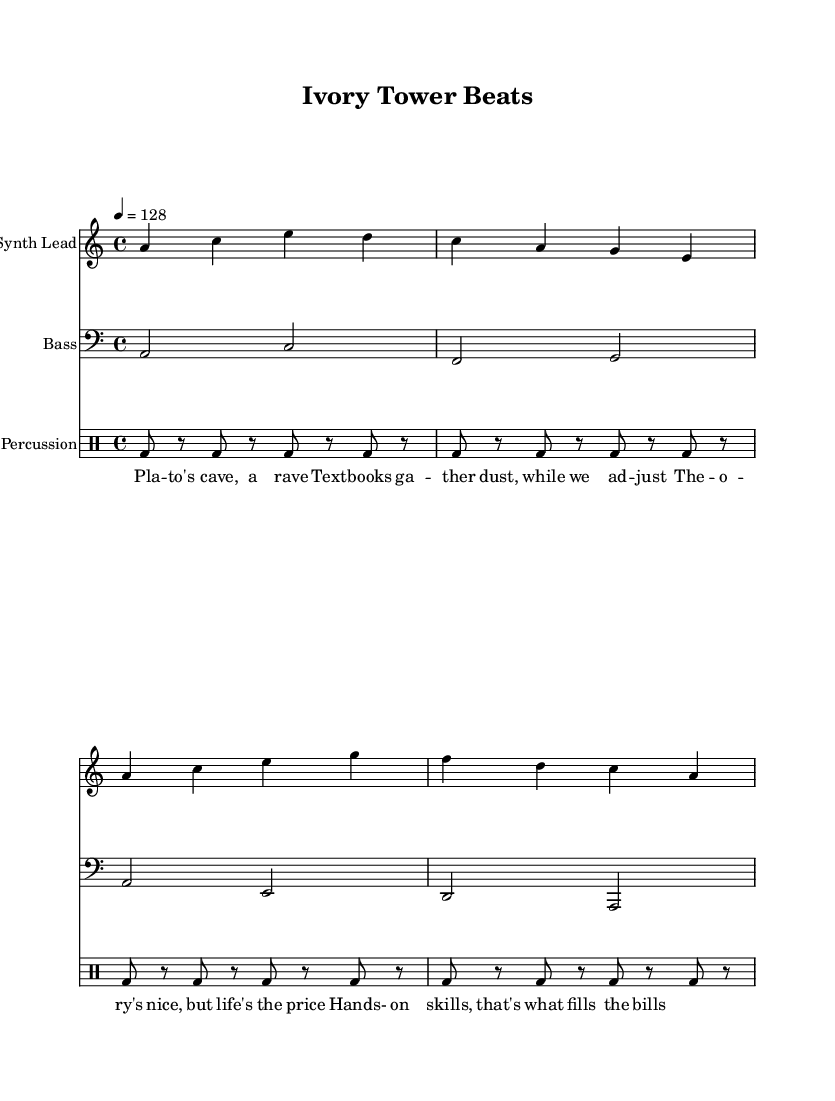What is the key signature of this music? The key signature in the piece is A minor, which is indicated by one sharp in the key signature box; A minor is the relative minor of C major.
Answer: A minor What is the time signature of this piece? The time signature, shown at the beginning of the score, is 4/4, meaning there are four beats in each measure and the quarter note gets one beat.
Answer: 4/4 What is the tempo marking for the music? The tempo marking indicates a speed of 128 beats per minute, as seen next to the tempo indication "4 = 128." This indicates the speed at which the piece should be performed.
Answer: 128 How many measures are in the synth lead part? By counting the vertical lines (bar lines) after each grouping of notes in the synth lead section, we find that there are a total of 4 measures.
Answer: 4 What type of music is this piece classified as? The music combines elements of house style with a spoken word component, as indicated by the title "Ivory Tower Beats" and the structure provided in the lyrics.
Answer: House What is the main theme conveyed in the spoken word lyrics? The spoken word lyrics critique academic learning while emphasizing the importance of practical skills, a recurrent theme when reviewing both the lyrics and the context of the music.
Answer: Practical skills Which instrument plays the bass line? The bass line is played by a staff labeled as "Bass," which denotes that the music notes are set for bass clef, commonly associated with lower-pitched instruments.
Answer: Bass 